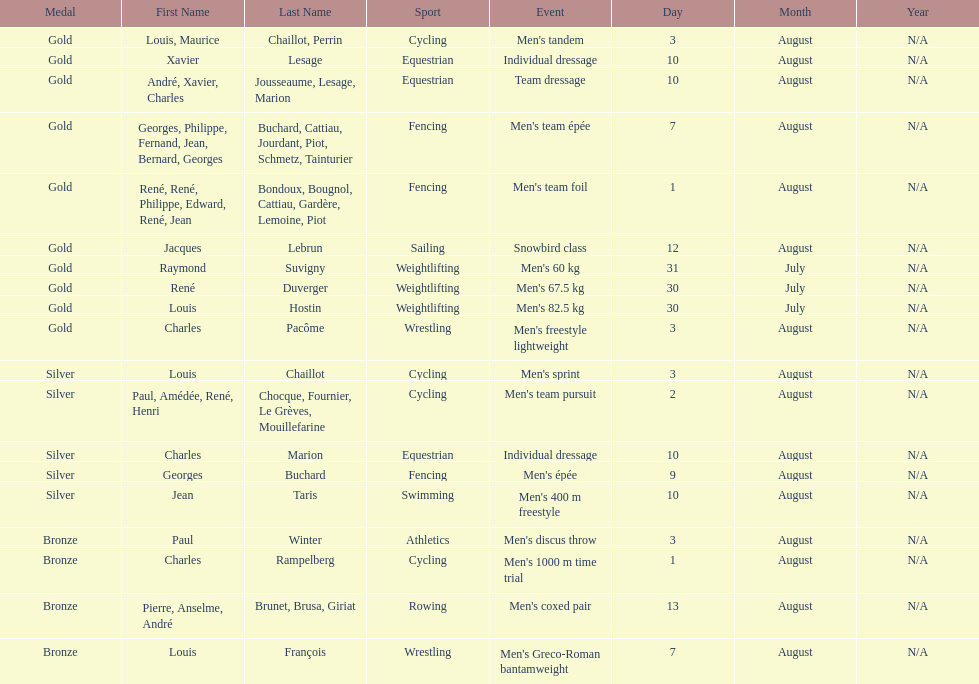What is next date that is listed after august 7th? August 1. 